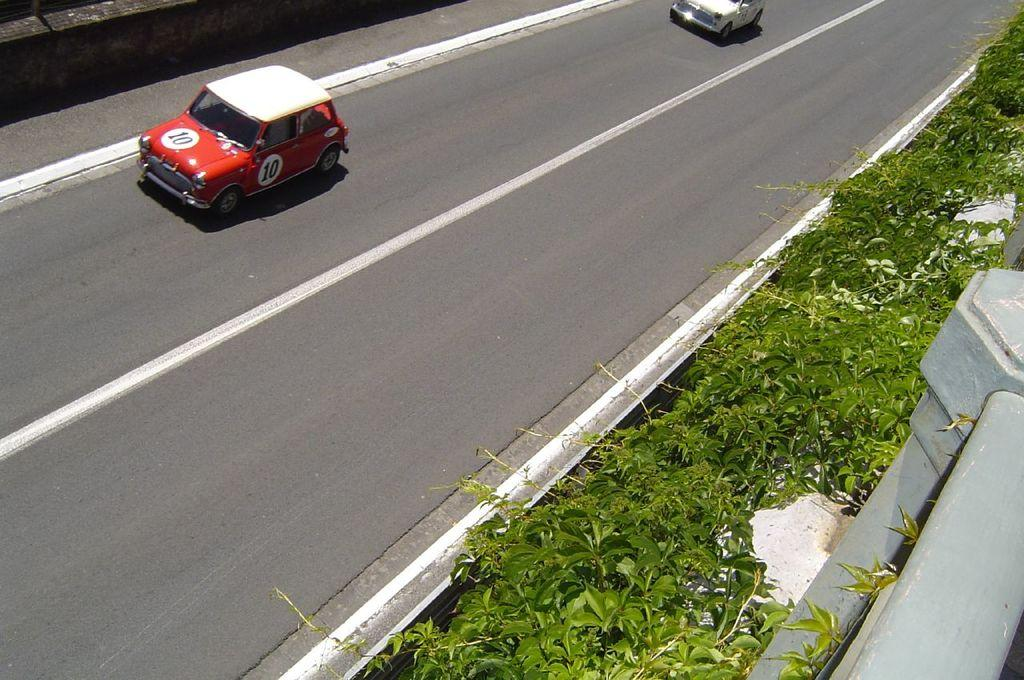What is happening on the road in the image? There are vehicles on the road in the image. What type of vegetation can be seen in the image? There are plants visible in the image. Can you describe any other objects present in the image? There are other objects present in the image, but their specific details are not mentioned in the provided facts. What is the wish of the box in the image? There is no box present in the image, and therefore no wish can be attributed to it. How does the growth of the plants affect the other objects in the image? The provided facts do not mention any growth of the plants, so we cannot determine how it might affect other objects in the image. 